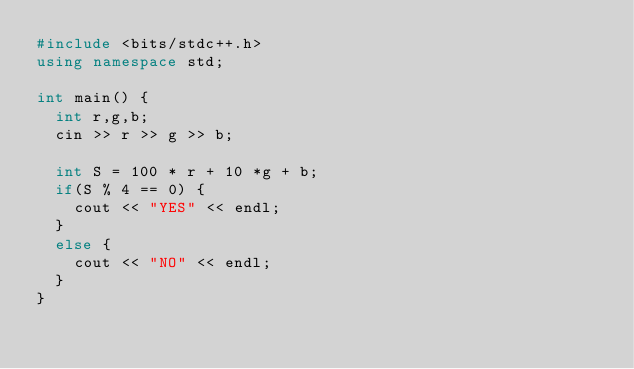Convert code to text. <code><loc_0><loc_0><loc_500><loc_500><_C++_>#include <bits/stdc++.h>
using namespace std;

int main() {
  int r,g,b;
  cin >> r >> g >> b;

  int S = 100 * r + 10 *g + b;
  if(S % 4 == 0) {
    cout << "YES" << endl;
  }
  else {
    cout << "NO" << endl;
  }
}</code> 